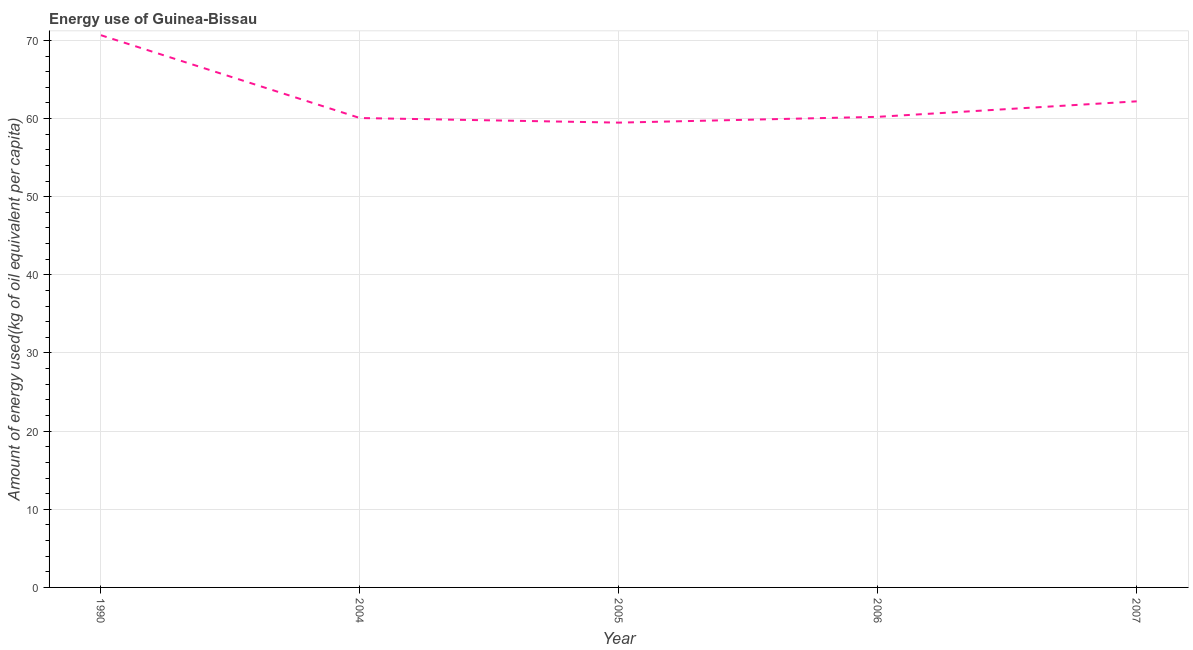What is the amount of energy used in 2005?
Offer a terse response. 59.48. Across all years, what is the maximum amount of energy used?
Offer a very short reply. 70.66. Across all years, what is the minimum amount of energy used?
Ensure brevity in your answer.  59.48. In which year was the amount of energy used maximum?
Your response must be concise. 1990. What is the sum of the amount of energy used?
Your answer should be very brief. 312.62. What is the difference between the amount of energy used in 2004 and 2005?
Your answer should be compact. 0.59. What is the average amount of energy used per year?
Your response must be concise. 62.52. What is the median amount of energy used?
Provide a succinct answer. 60.22. Do a majority of the years between 1990 and 2006 (inclusive) have amount of energy used greater than 38 kg?
Give a very brief answer. Yes. What is the ratio of the amount of energy used in 1990 to that in 2005?
Ensure brevity in your answer.  1.19. What is the difference between the highest and the second highest amount of energy used?
Offer a very short reply. 8.46. What is the difference between the highest and the lowest amount of energy used?
Provide a short and direct response. 11.19. In how many years, is the amount of energy used greater than the average amount of energy used taken over all years?
Make the answer very short. 1. Does the amount of energy used monotonically increase over the years?
Ensure brevity in your answer.  No. How many lines are there?
Offer a very short reply. 1. What is the difference between two consecutive major ticks on the Y-axis?
Offer a terse response. 10. Are the values on the major ticks of Y-axis written in scientific E-notation?
Ensure brevity in your answer.  No. What is the title of the graph?
Provide a succinct answer. Energy use of Guinea-Bissau. What is the label or title of the Y-axis?
Provide a short and direct response. Amount of energy used(kg of oil equivalent per capita). What is the Amount of energy used(kg of oil equivalent per capita) of 1990?
Ensure brevity in your answer.  70.66. What is the Amount of energy used(kg of oil equivalent per capita) in 2004?
Offer a very short reply. 60.06. What is the Amount of energy used(kg of oil equivalent per capita) in 2005?
Your answer should be very brief. 59.48. What is the Amount of energy used(kg of oil equivalent per capita) of 2006?
Make the answer very short. 60.22. What is the Amount of energy used(kg of oil equivalent per capita) in 2007?
Give a very brief answer. 62.2. What is the difference between the Amount of energy used(kg of oil equivalent per capita) in 1990 and 2004?
Provide a short and direct response. 10.6. What is the difference between the Amount of energy used(kg of oil equivalent per capita) in 1990 and 2005?
Offer a very short reply. 11.19. What is the difference between the Amount of energy used(kg of oil equivalent per capita) in 1990 and 2006?
Your response must be concise. 10.45. What is the difference between the Amount of energy used(kg of oil equivalent per capita) in 1990 and 2007?
Offer a very short reply. 8.46. What is the difference between the Amount of energy used(kg of oil equivalent per capita) in 2004 and 2005?
Offer a very short reply. 0.59. What is the difference between the Amount of energy used(kg of oil equivalent per capita) in 2004 and 2006?
Your response must be concise. -0.15. What is the difference between the Amount of energy used(kg of oil equivalent per capita) in 2004 and 2007?
Keep it short and to the point. -2.14. What is the difference between the Amount of energy used(kg of oil equivalent per capita) in 2005 and 2006?
Your answer should be compact. -0.74. What is the difference between the Amount of energy used(kg of oil equivalent per capita) in 2005 and 2007?
Give a very brief answer. -2.72. What is the difference between the Amount of energy used(kg of oil equivalent per capita) in 2006 and 2007?
Make the answer very short. -1.98. What is the ratio of the Amount of energy used(kg of oil equivalent per capita) in 1990 to that in 2004?
Give a very brief answer. 1.18. What is the ratio of the Amount of energy used(kg of oil equivalent per capita) in 1990 to that in 2005?
Provide a succinct answer. 1.19. What is the ratio of the Amount of energy used(kg of oil equivalent per capita) in 1990 to that in 2006?
Make the answer very short. 1.17. What is the ratio of the Amount of energy used(kg of oil equivalent per capita) in 1990 to that in 2007?
Provide a short and direct response. 1.14. What is the ratio of the Amount of energy used(kg of oil equivalent per capita) in 2004 to that in 2005?
Your answer should be compact. 1.01. What is the ratio of the Amount of energy used(kg of oil equivalent per capita) in 2004 to that in 2006?
Provide a succinct answer. 1. What is the ratio of the Amount of energy used(kg of oil equivalent per capita) in 2005 to that in 2006?
Your answer should be compact. 0.99. What is the ratio of the Amount of energy used(kg of oil equivalent per capita) in 2005 to that in 2007?
Your response must be concise. 0.96. 